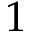<formula> <loc_0><loc_0><loc_500><loc_500>1</formula> 